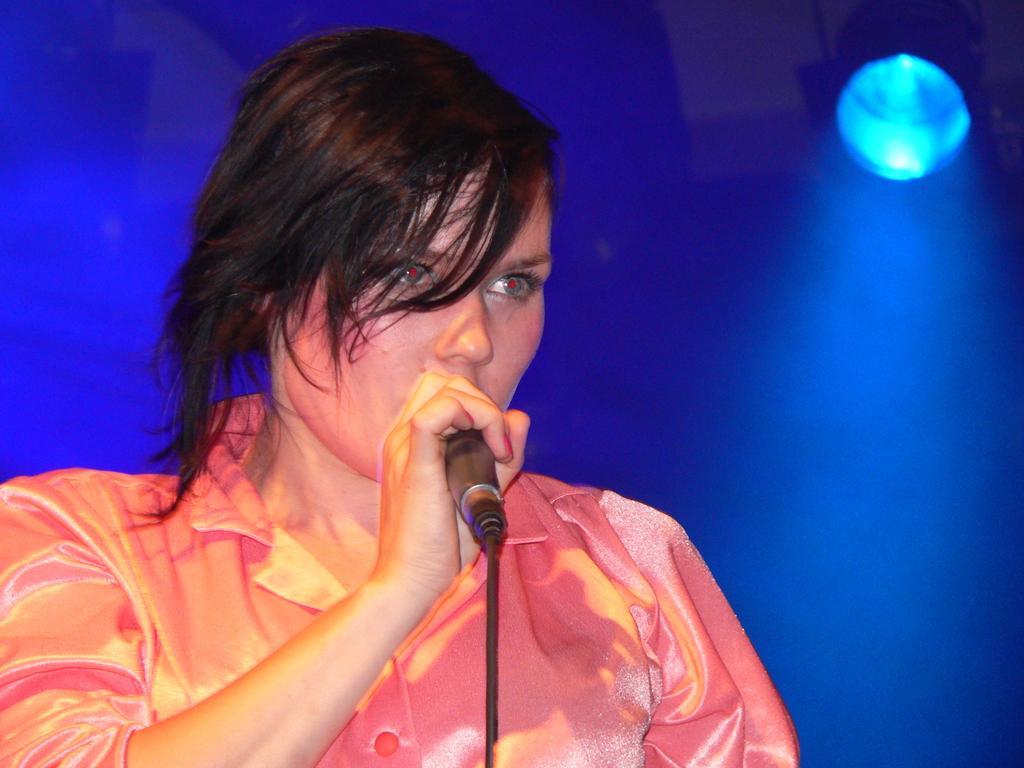Please provide a concise description of this image. As we can see in the image there is a woman holding mic. 